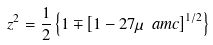<formula> <loc_0><loc_0><loc_500><loc_500>z ^ { 2 } = \frac { 1 } { 2 } \left \{ 1 \mp \left [ 1 - 2 7 \mu \ a m c \right ] ^ { 1 / 2 } \right \}</formula> 